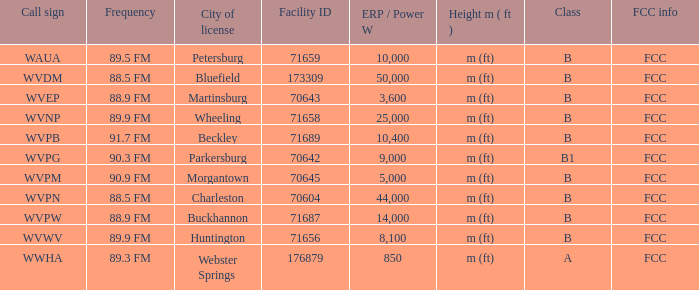Which city possesses the a class license? Webster Springs. 